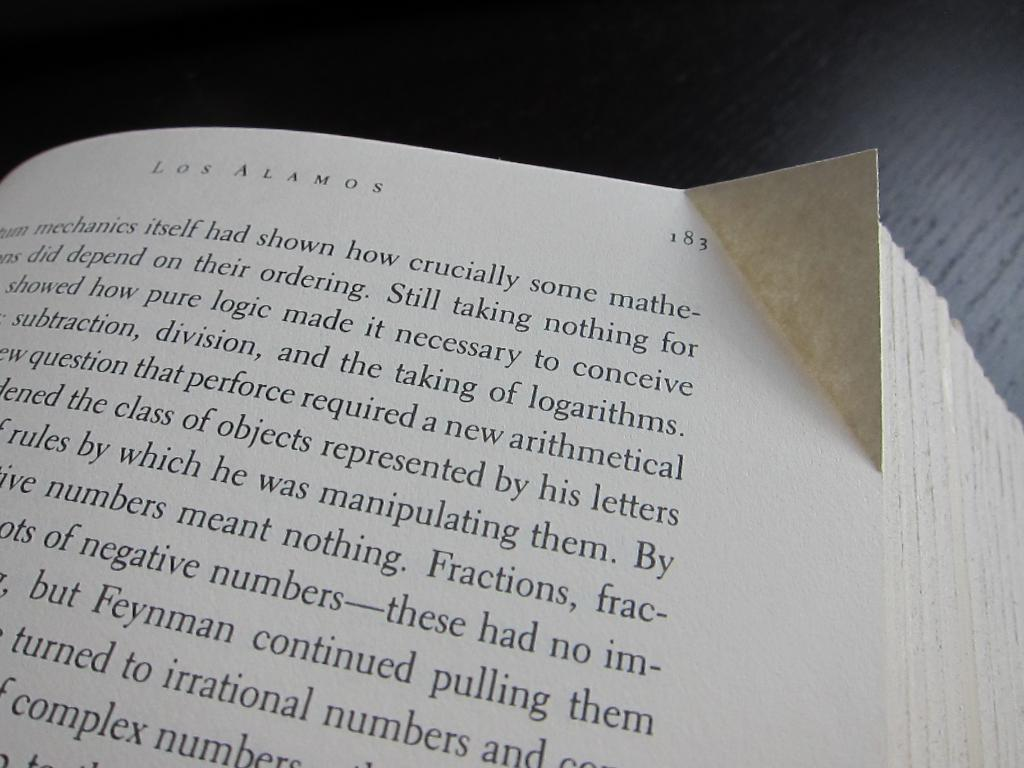<image>
Give a short and clear explanation of the subsequent image. a book called los alamos turned to page 183 